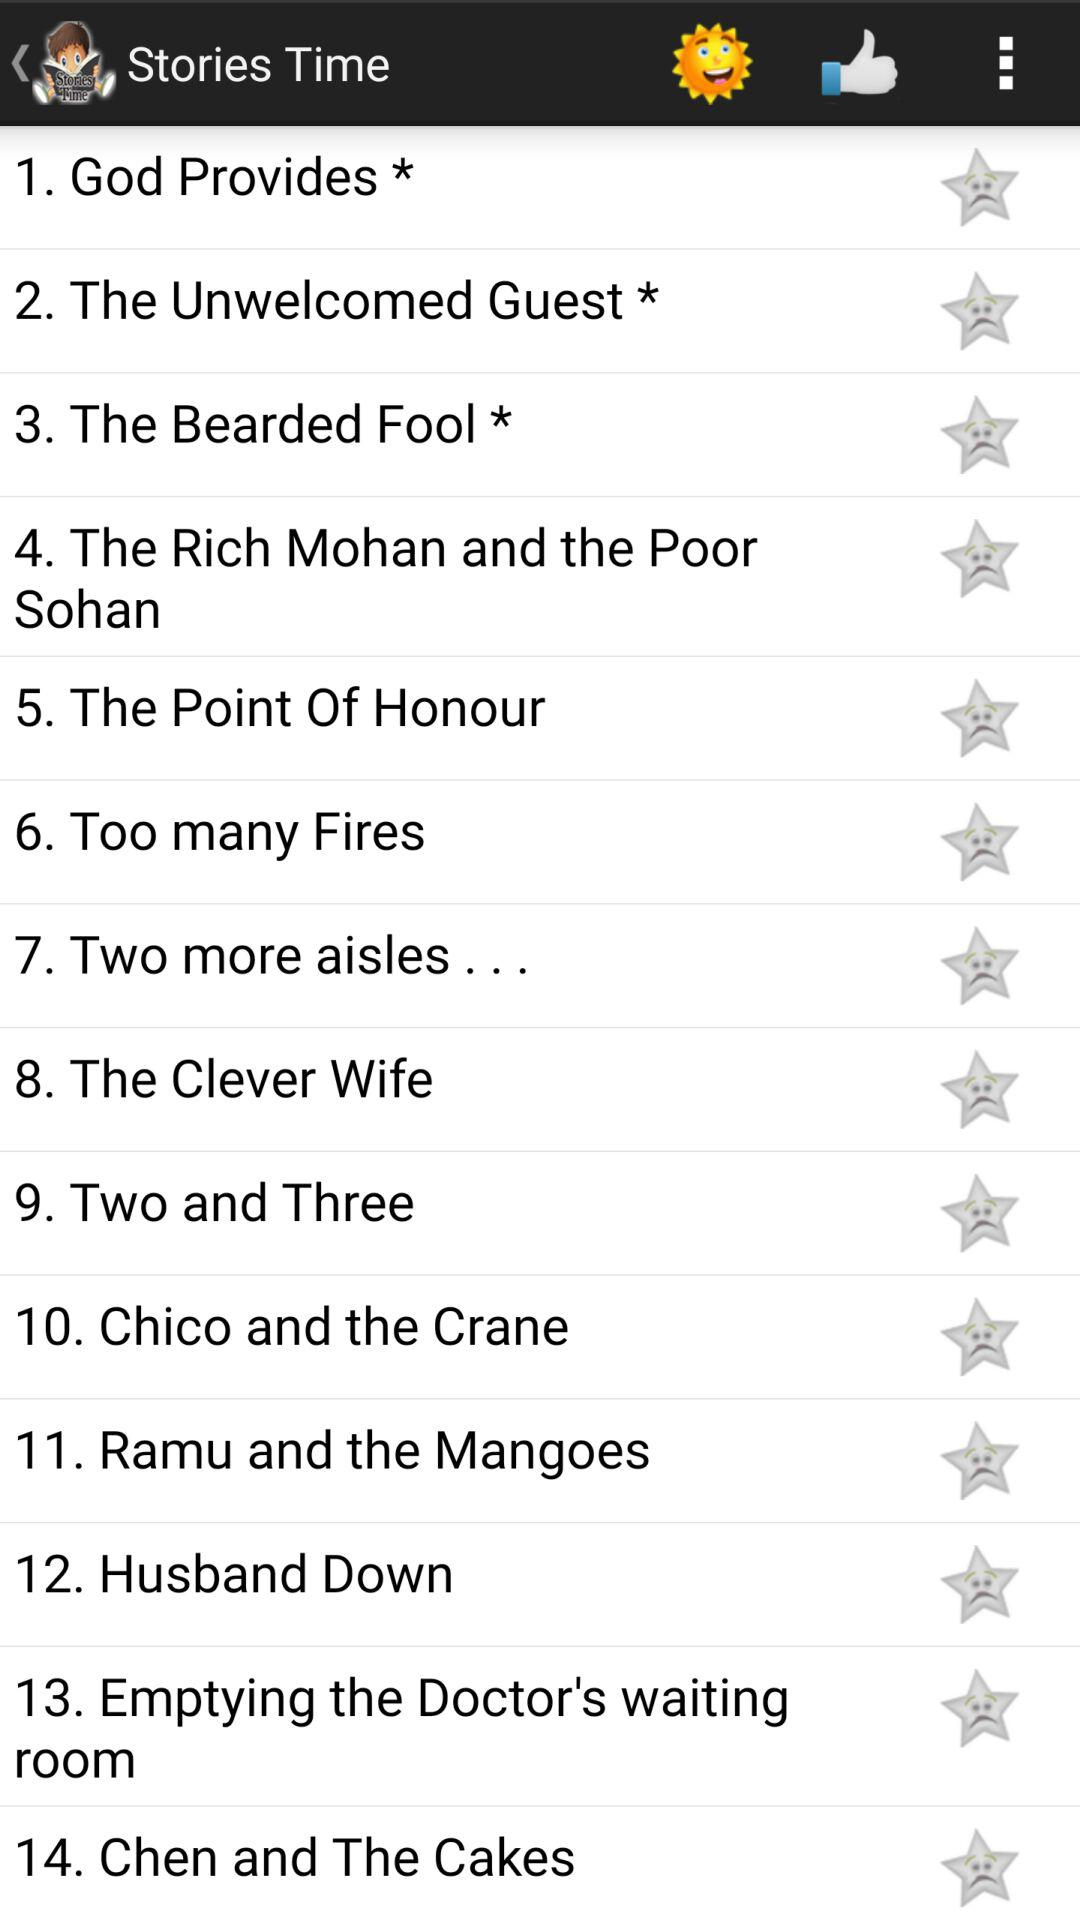What is the name of the application? The name of the application is "Stories Time". 